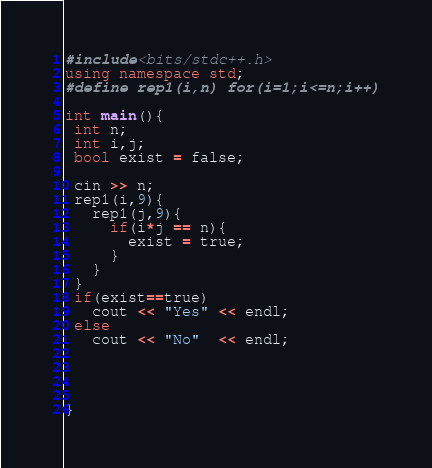Convert code to text. <code><loc_0><loc_0><loc_500><loc_500><_C++_>#include<bits/stdc++.h>
using namespace std;
#define rep1(i,n) for(i=1;i<=n;i++)

int main(){
 int n;
 int i,j;
 bool exist = false;
 
 cin >> n;
 rep1(i,9){
   rep1(j,9){
     if(i*j == n){
       exist = true;
     }
   }
 }
 if(exist==true)
   cout << "Yes" << endl;
 else
   cout << "No"  << endl;
   
 
 
  
}</code> 